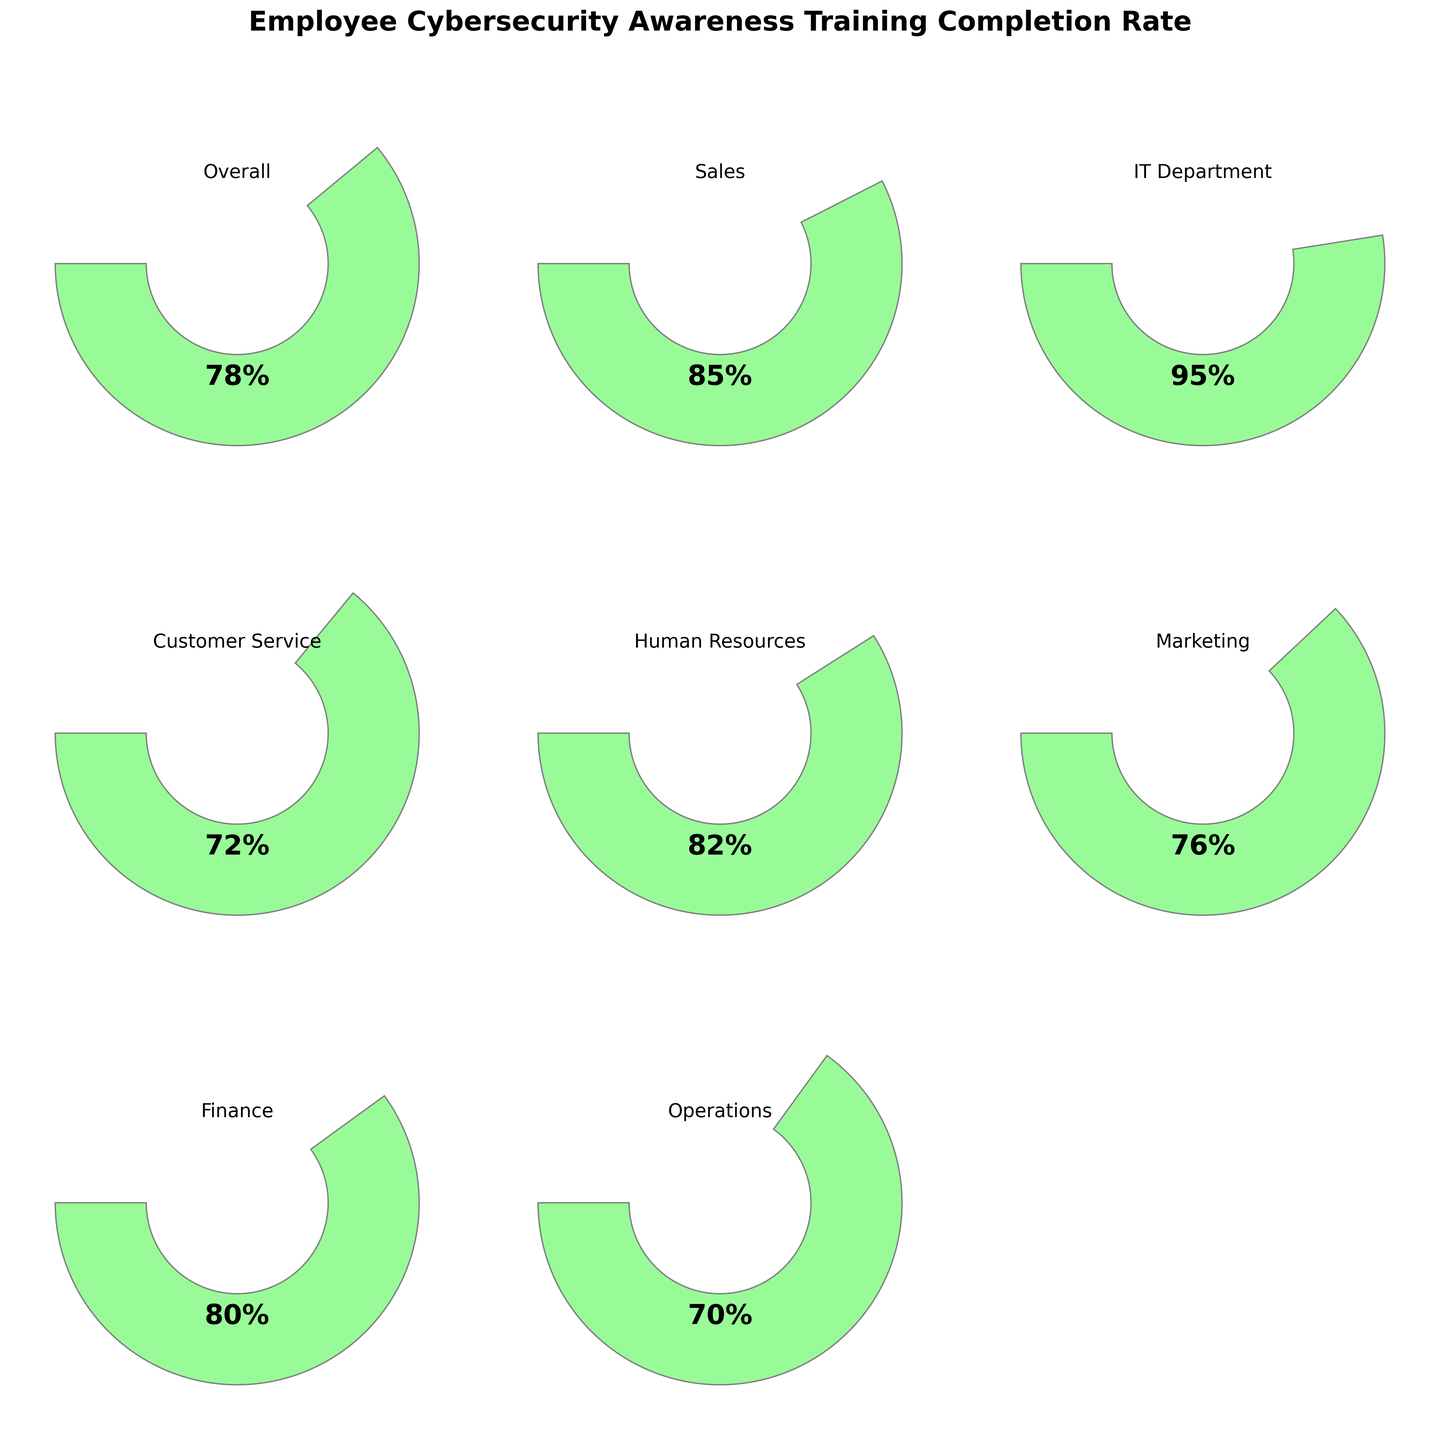What is the overall completion rate for employee cybersecurity awareness training? The gauge chart labeled "Overall" shows a completion rate of 78%.
Answer: 78% Which department has the highest completion rate for cybersecurity awareness training? By looking at all the gauge charts, the IT Department has the highest completion rate at 95%.
Answer: IT Department Compare the completion rates between Sales and Marketing. Which department has a higher completion rate? The Sales department has a completion rate of 85%, while Marketing has a rate of 76%. Therefore, Sales has a higher completion rate.
Answer: Sales What is the difference in completion rates between Human Resources and Customer Service? The completion rate for Human Resources is 82% and for Customer Service, it is 72%. The difference is 82% - 72% = 10%.
Answer: 10% Which departments have a completion rate below 80%? By examining the gauge charts, the departments with rates below 80% are Customer Service (72%), Marketing (76%), and Operations (70%).
Answer: Customer Service, Marketing, Operations What is the average completion rate across all departments? To find the average, sum the completion rates and divide by the number of categories. The sum is 78 + 85 + 95 + 72 + 82 + 76 + 80 + 70 = 638. The number of categories is 8, so the average is 638 / 8 = 79.75%.
Answer: 79.75% How many departments have a completion rate of 80% or higher? From the gauge charts, the departments with completion rates of 80% or higher are: Sales (85%), IT Department (95%), Human Resources (82%), Finance (80%), and Overall (78% does not count here). This gives us 4 departments.
Answer: 4 Are there more departments with completion rates above or below 80%? There are 4 departments with rates above 80% (Sales, IT Department, Human Resources, and Finance) and 3 departments below 80% (Customer Service, Marketing, and Operations). So, more departments have rates above 80%.
Answer: Above 80% Which department has the lowest completion rate, and what is it? Among the departments, Operations has the lowest completion rate at 70%.
Answer: Operations Is the completion rate for the Finance department above the overall completion rate? The Finance department has a completion rate of 80%, which is higher than the overall rate of 78%.
Answer: Yes 